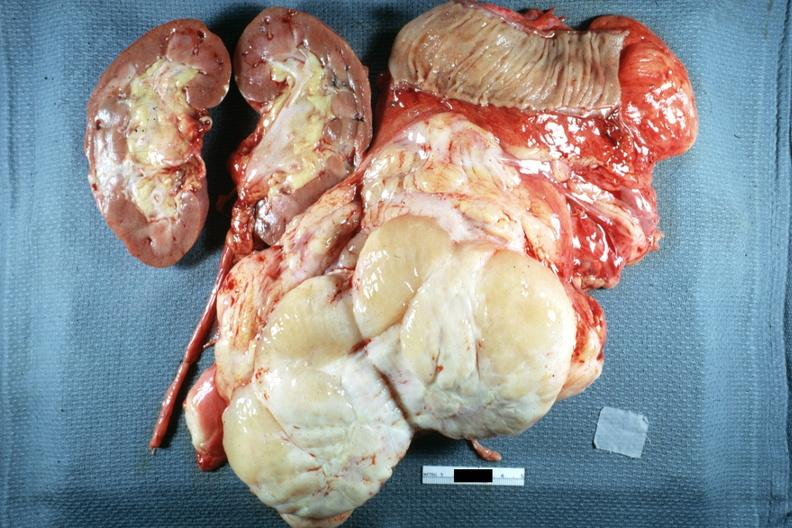what is present?
Answer the question using a single word or phrase. Peritoneum 